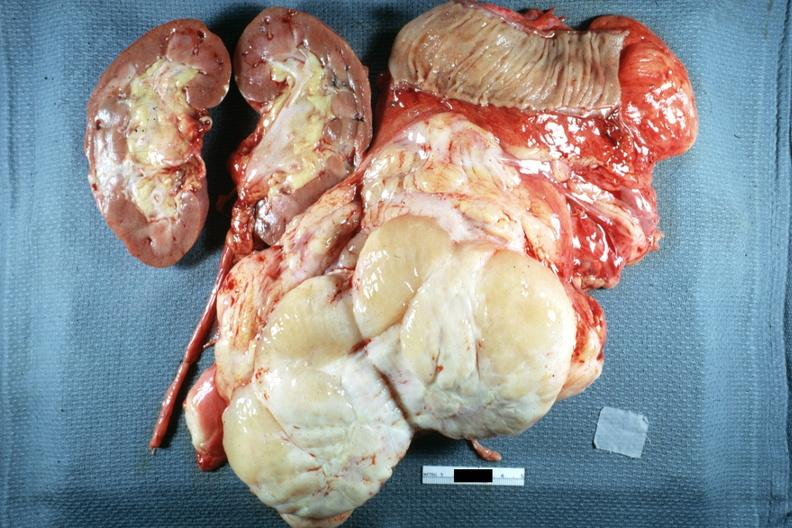what is present?
Answer the question using a single word or phrase. Peritoneum 